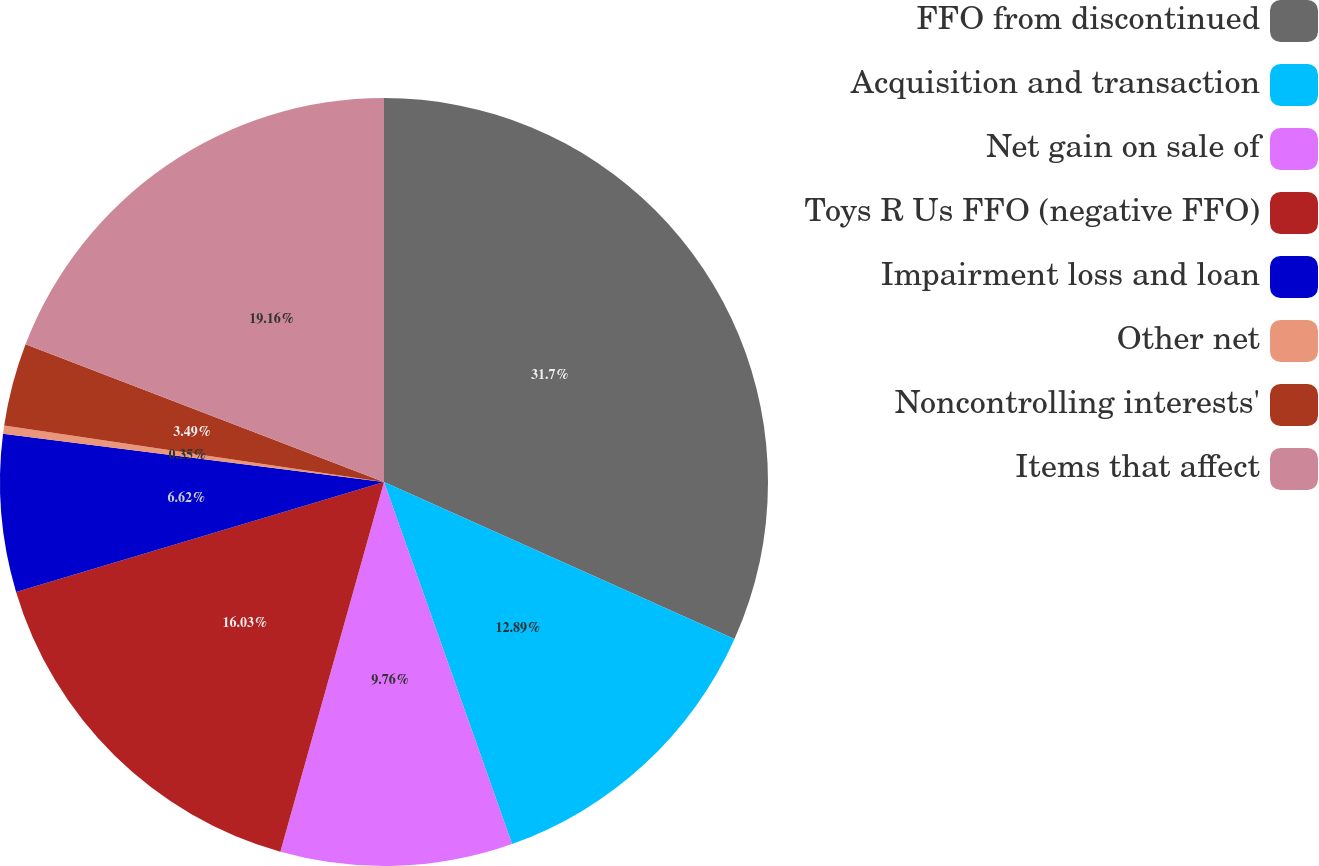<chart> <loc_0><loc_0><loc_500><loc_500><pie_chart><fcel>FFO from discontinued<fcel>Acquisition and transaction<fcel>Net gain on sale of<fcel>Toys R Us FFO (negative FFO)<fcel>Impairment loss and loan<fcel>Other net<fcel>Noncontrolling interests'<fcel>Items that affect<nl><fcel>31.7%<fcel>12.89%<fcel>9.76%<fcel>16.03%<fcel>6.62%<fcel>0.35%<fcel>3.49%<fcel>19.16%<nl></chart> 